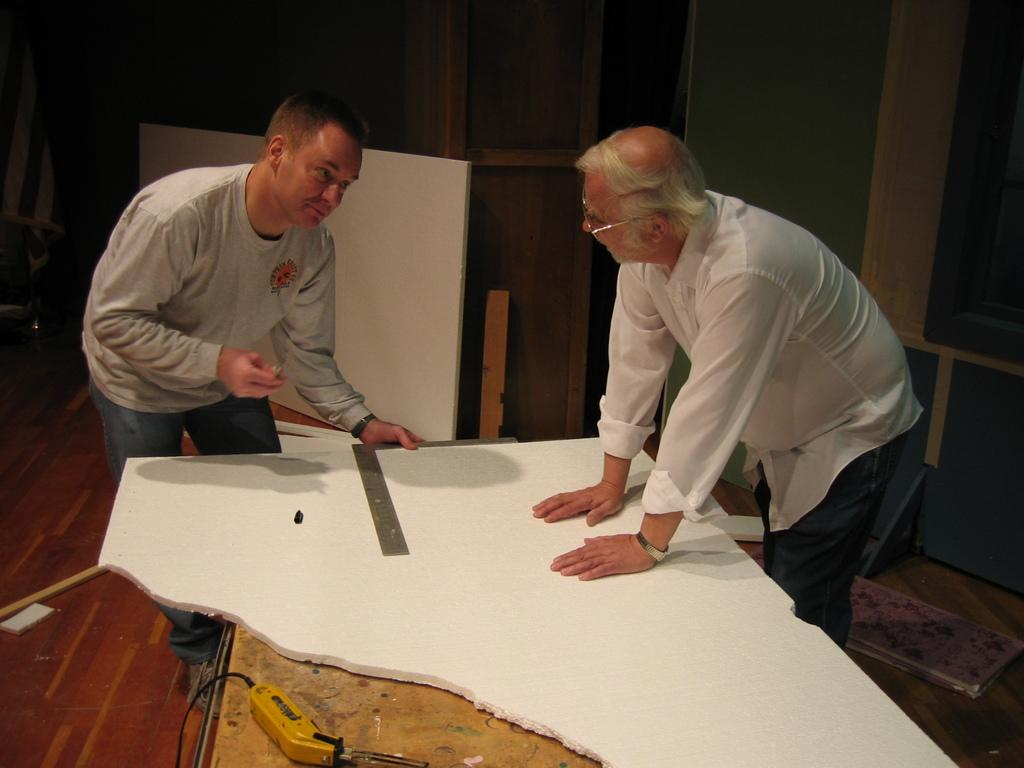How many people are in the image? There are two men in the image. What are the men doing in the image? The men are standing in front of a table. What can be seen on the table in the image? There are objects on the table. What type of playground equipment can be seen in the image? There is no playground equipment present in the image. What is the price of the objects on the table in the image? The facts do not provide any information about the price of the objects on the table. 